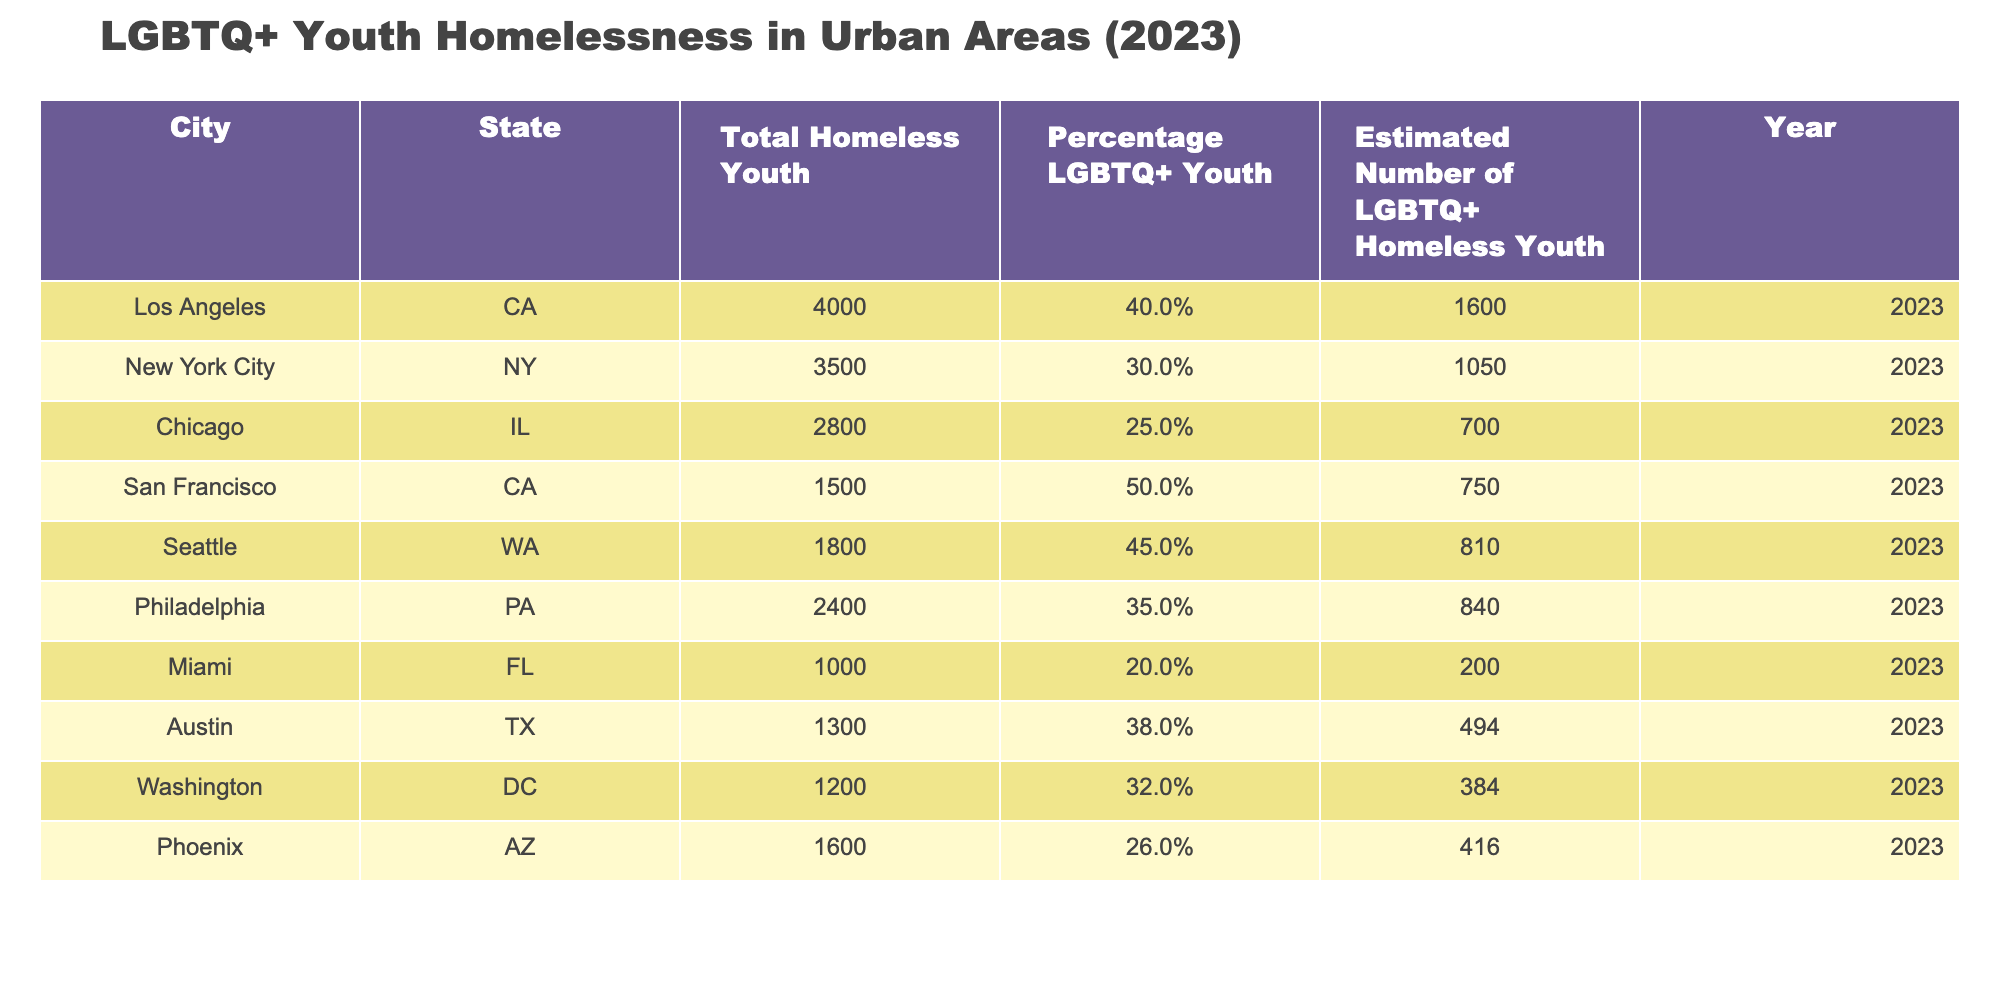What is the estimated number of LGBTQ+ homeless youth in Los Angeles? The table provides a direct value for the "Estimated Number of LGBTQ+ Homeless Youth" corresponding to Los Angeles, which is listed as 1600.
Answer: 1600 What is the total number of homeless youth in Chicago? The total number of homeless youth for Chicago is specified in the data as 2800.
Answer: 2800 Which city has the highest percentage of LGBTQ+ youth among homeless youth? Looking at the "Percentage LGBTQ+ Youth" column, San Francisco has the highest value listed at 50%.
Answer: San Francisco What is the average estimated number of LGBTQ+ homeless youth across all listed cities? To find the average, first, sum the estimated numbers: 1600 + 1050 + 700 + 750 + 810 + 840 + 200 + 494 + 384 + 416 = 6,154. There are 10 cities, so we divide by 10, resulting in an average of approximately 615.4.
Answer: 615.4 Is the estimated number of LGBTQ+ homeless youth in Miami higher than in Washington, DC? The estimated number for Miami is 200, and for Washington, DC, it is 384. Since 200 is less than 384, the answer is no.
Answer: No What percentage of total homeless youth in Seattle are LGBTQ+? The table indicates that the "Percentage LGBTQ+ Youth" in Seattle is 45%.
Answer: 45% Which city has the lowest number of total homeless youth? By comparing the "Total Homeless Youth" values, Miami has the lowest number with 1000.
Answer: Miami How many more LGBTQ+ homeless youth are there in San Francisco compared to Chicago? The estimated number of LGBTQ+ homeless youth in San Francisco is 750, while in Chicago, it is 700. Therefore, 750 - 700 equals 50, indicating there are 50 more in San Francisco.
Answer: 50 Does New York City have a higher percentage of LGBTQ+ homeless youth compared to Phoenix? New York City's percentage is 30%, while Phoenix's is 26%. Since 30% is greater than 26%, the answer is yes.
Answer: Yes 